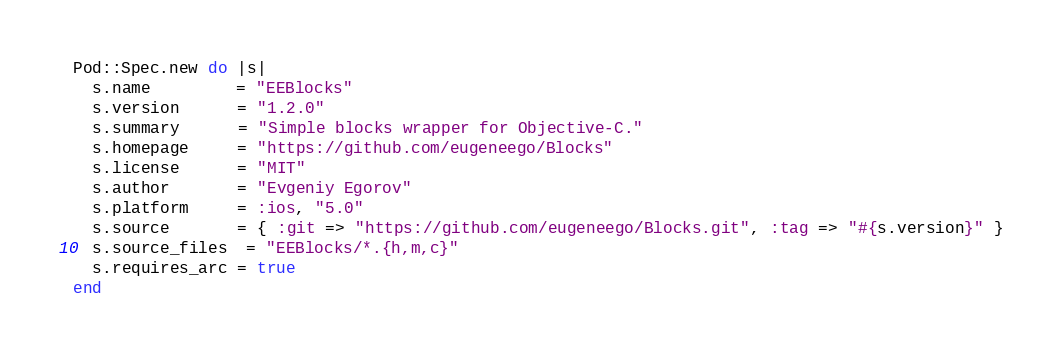Convert code to text. <code><loc_0><loc_0><loc_500><loc_500><_Ruby_>Pod::Spec.new do |s|
  s.name         = "EEBlocks"
  s.version      = "1.2.0"
  s.summary      = "Simple blocks wrapper for Objective-C."
  s.homepage     = "https://github.com/eugeneego/Blocks"
  s.license      = "MIT"
  s.author       = "Evgeniy Egorov"
  s.platform     = :ios, "5.0"
  s.source       = { :git => "https://github.com/eugeneego/Blocks.git", :tag => "#{s.version}" }
  s.source_files  = "EEBlocks/*.{h,m,c}"
  s.requires_arc = true
end
</code> 